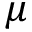<formula> <loc_0><loc_0><loc_500><loc_500>\mu</formula> 